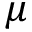<formula> <loc_0><loc_0><loc_500><loc_500>\mu</formula> 